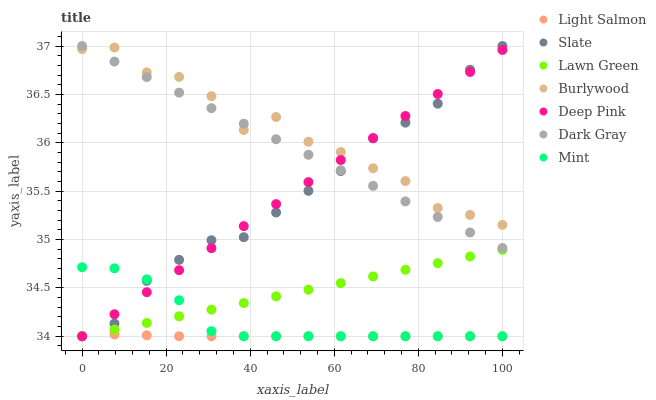Does Light Salmon have the minimum area under the curve?
Answer yes or no. Yes. Does Burlywood have the maximum area under the curve?
Answer yes or no. Yes. Does Deep Pink have the minimum area under the curve?
Answer yes or no. No. Does Deep Pink have the maximum area under the curve?
Answer yes or no. No. Is Deep Pink the smoothest?
Answer yes or no. Yes. Is Burlywood the roughest?
Answer yes or no. Yes. Is Light Salmon the smoothest?
Answer yes or no. No. Is Light Salmon the roughest?
Answer yes or no. No. Does Lawn Green have the lowest value?
Answer yes or no. Yes. Does Burlywood have the lowest value?
Answer yes or no. No. Does Dark Gray have the highest value?
Answer yes or no. Yes. Does Deep Pink have the highest value?
Answer yes or no. No. Is Mint less than Burlywood?
Answer yes or no. Yes. Is Burlywood greater than Lawn Green?
Answer yes or no. Yes. Does Light Salmon intersect Mint?
Answer yes or no. Yes. Is Light Salmon less than Mint?
Answer yes or no. No. Is Light Salmon greater than Mint?
Answer yes or no. No. Does Mint intersect Burlywood?
Answer yes or no. No. 